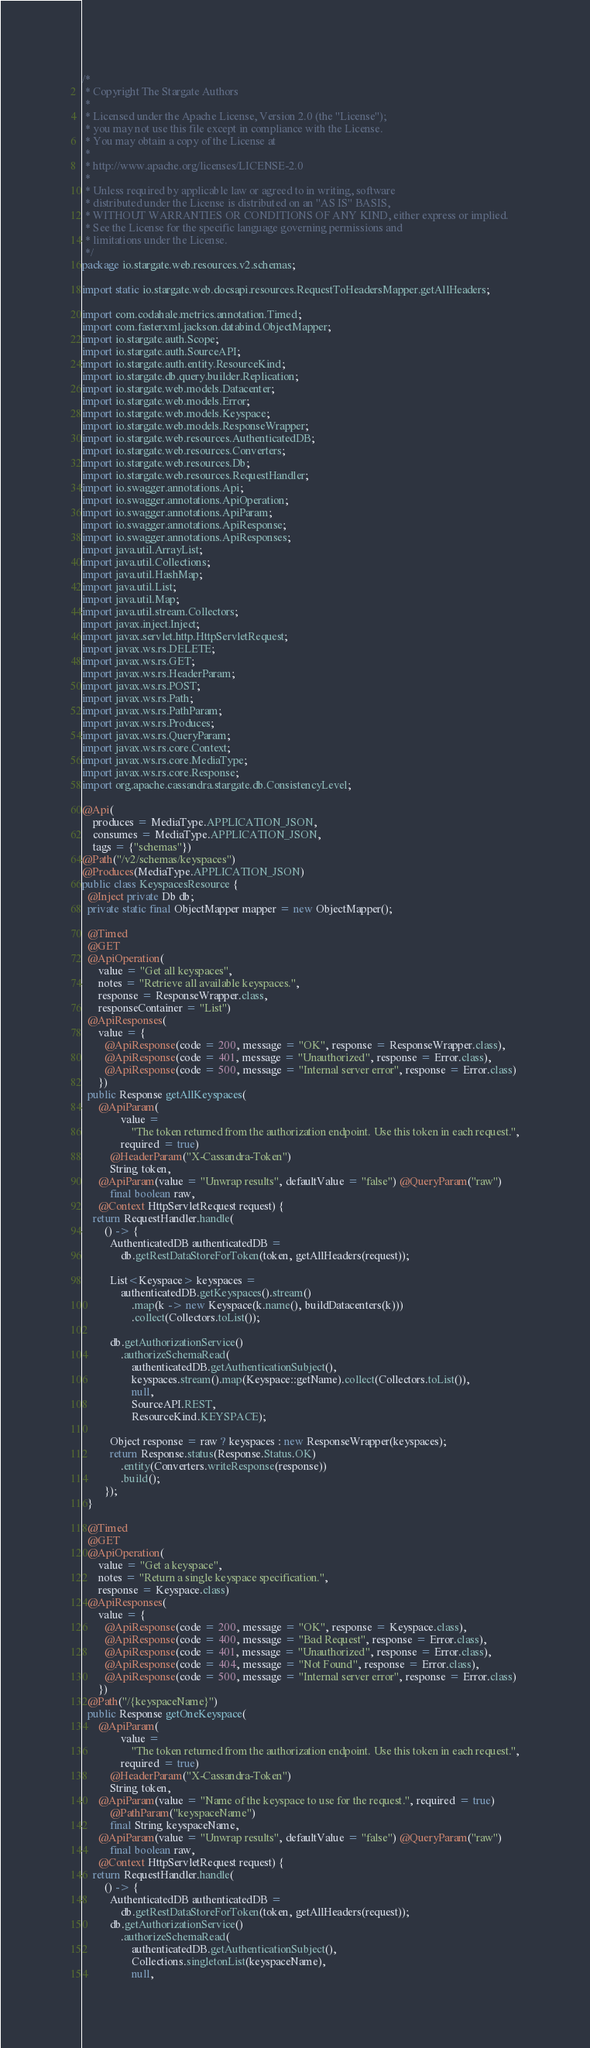<code> <loc_0><loc_0><loc_500><loc_500><_Java_>/*
 * Copyright The Stargate Authors
 *
 * Licensed under the Apache License, Version 2.0 (the "License");
 * you may not use this file except in compliance with the License.
 * You may obtain a copy of the License at
 *
 * http://www.apache.org/licenses/LICENSE-2.0
 *
 * Unless required by applicable law or agreed to in writing, software
 * distributed under the License is distributed on an "AS IS" BASIS,
 * WITHOUT WARRANTIES OR CONDITIONS OF ANY KIND, either express or implied.
 * See the License for the specific language governing permissions and
 * limitations under the License.
 */
package io.stargate.web.resources.v2.schemas;

import static io.stargate.web.docsapi.resources.RequestToHeadersMapper.getAllHeaders;

import com.codahale.metrics.annotation.Timed;
import com.fasterxml.jackson.databind.ObjectMapper;
import io.stargate.auth.Scope;
import io.stargate.auth.SourceAPI;
import io.stargate.auth.entity.ResourceKind;
import io.stargate.db.query.builder.Replication;
import io.stargate.web.models.Datacenter;
import io.stargate.web.models.Error;
import io.stargate.web.models.Keyspace;
import io.stargate.web.models.ResponseWrapper;
import io.stargate.web.resources.AuthenticatedDB;
import io.stargate.web.resources.Converters;
import io.stargate.web.resources.Db;
import io.stargate.web.resources.RequestHandler;
import io.swagger.annotations.Api;
import io.swagger.annotations.ApiOperation;
import io.swagger.annotations.ApiParam;
import io.swagger.annotations.ApiResponse;
import io.swagger.annotations.ApiResponses;
import java.util.ArrayList;
import java.util.Collections;
import java.util.HashMap;
import java.util.List;
import java.util.Map;
import java.util.stream.Collectors;
import javax.inject.Inject;
import javax.servlet.http.HttpServletRequest;
import javax.ws.rs.DELETE;
import javax.ws.rs.GET;
import javax.ws.rs.HeaderParam;
import javax.ws.rs.POST;
import javax.ws.rs.Path;
import javax.ws.rs.PathParam;
import javax.ws.rs.Produces;
import javax.ws.rs.QueryParam;
import javax.ws.rs.core.Context;
import javax.ws.rs.core.MediaType;
import javax.ws.rs.core.Response;
import org.apache.cassandra.stargate.db.ConsistencyLevel;

@Api(
    produces = MediaType.APPLICATION_JSON,
    consumes = MediaType.APPLICATION_JSON,
    tags = {"schemas"})
@Path("/v2/schemas/keyspaces")
@Produces(MediaType.APPLICATION_JSON)
public class KeyspacesResource {
  @Inject private Db db;
  private static final ObjectMapper mapper = new ObjectMapper();

  @Timed
  @GET
  @ApiOperation(
      value = "Get all keyspaces",
      notes = "Retrieve all available keyspaces.",
      response = ResponseWrapper.class,
      responseContainer = "List")
  @ApiResponses(
      value = {
        @ApiResponse(code = 200, message = "OK", response = ResponseWrapper.class),
        @ApiResponse(code = 401, message = "Unauthorized", response = Error.class),
        @ApiResponse(code = 500, message = "Internal server error", response = Error.class)
      })
  public Response getAllKeyspaces(
      @ApiParam(
              value =
                  "The token returned from the authorization endpoint. Use this token in each request.",
              required = true)
          @HeaderParam("X-Cassandra-Token")
          String token,
      @ApiParam(value = "Unwrap results", defaultValue = "false") @QueryParam("raw")
          final boolean raw,
      @Context HttpServletRequest request) {
    return RequestHandler.handle(
        () -> {
          AuthenticatedDB authenticatedDB =
              db.getRestDataStoreForToken(token, getAllHeaders(request));

          List<Keyspace> keyspaces =
              authenticatedDB.getKeyspaces().stream()
                  .map(k -> new Keyspace(k.name(), buildDatacenters(k)))
                  .collect(Collectors.toList());

          db.getAuthorizationService()
              .authorizeSchemaRead(
                  authenticatedDB.getAuthenticationSubject(),
                  keyspaces.stream().map(Keyspace::getName).collect(Collectors.toList()),
                  null,
                  SourceAPI.REST,
                  ResourceKind.KEYSPACE);

          Object response = raw ? keyspaces : new ResponseWrapper(keyspaces);
          return Response.status(Response.Status.OK)
              .entity(Converters.writeResponse(response))
              .build();
        });
  }

  @Timed
  @GET
  @ApiOperation(
      value = "Get a keyspace",
      notes = "Return a single keyspace specification.",
      response = Keyspace.class)
  @ApiResponses(
      value = {
        @ApiResponse(code = 200, message = "OK", response = Keyspace.class),
        @ApiResponse(code = 400, message = "Bad Request", response = Error.class),
        @ApiResponse(code = 401, message = "Unauthorized", response = Error.class),
        @ApiResponse(code = 404, message = "Not Found", response = Error.class),
        @ApiResponse(code = 500, message = "Internal server error", response = Error.class)
      })
  @Path("/{keyspaceName}")
  public Response getOneKeyspace(
      @ApiParam(
              value =
                  "The token returned from the authorization endpoint. Use this token in each request.",
              required = true)
          @HeaderParam("X-Cassandra-Token")
          String token,
      @ApiParam(value = "Name of the keyspace to use for the request.", required = true)
          @PathParam("keyspaceName")
          final String keyspaceName,
      @ApiParam(value = "Unwrap results", defaultValue = "false") @QueryParam("raw")
          final boolean raw,
      @Context HttpServletRequest request) {
    return RequestHandler.handle(
        () -> {
          AuthenticatedDB authenticatedDB =
              db.getRestDataStoreForToken(token, getAllHeaders(request));
          db.getAuthorizationService()
              .authorizeSchemaRead(
                  authenticatedDB.getAuthenticationSubject(),
                  Collections.singletonList(keyspaceName),
                  null,</code> 